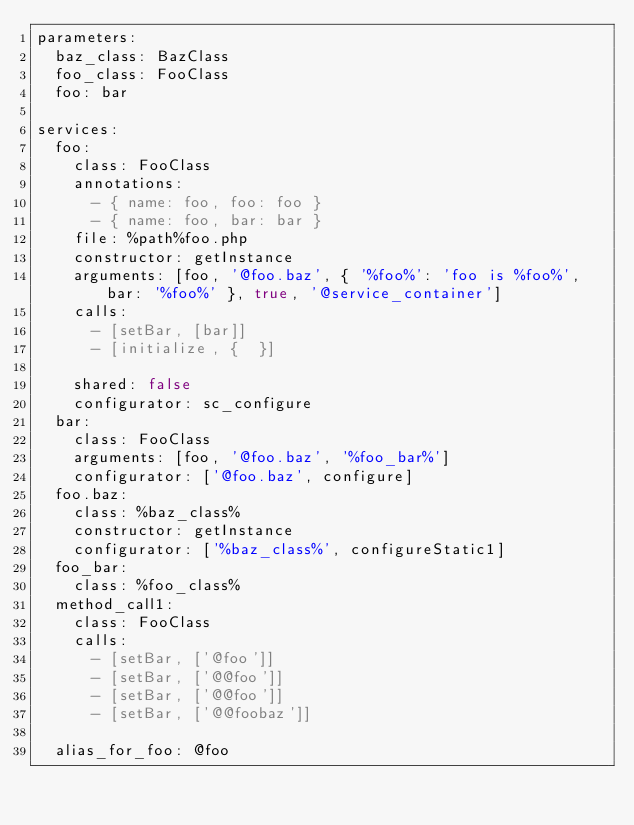Convert code to text. <code><loc_0><loc_0><loc_500><loc_500><_YAML_>parameters:
  baz_class: BazClass
  foo_class: FooClass
  foo: bar

services:
  foo:
    class: FooClass
    annotations:
      - { name: foo, foo: foo }
      - { name: foo, bar: bar }
    file: %path%foo.php
    constructor: getInstance
    arguments: [foo, '@foo.baz', { '%foo%': 'foo is %foo%', bar: '%foo%' }, true, '@service_container']
    calls:
      - [setBar, [bar]]
      - [initialize, {  }]
      
    shared: false
    configurator: sc_configure
  bar:
    class: FooClass
    arguments: [foo, '@foo.baz', '%foo_bar%']
    configurator: ['@foo.baz', configure]
  foo.baz:
    class: %baz_class%
    constructor: getInstance
    configurator: ['%baz_class%', configureStatic1]
  foo_bar:
    class: %foo_class%
  method_call1:
    class: FooClass
    calls:
      - [setBar, ['@foo']]
      - [setBar, ['@@foo']]
      - [setBar, ['@@foo']]
      - [setBar, ['@@foobaz']]
      
  alias_for_foo: @foo
</code> 